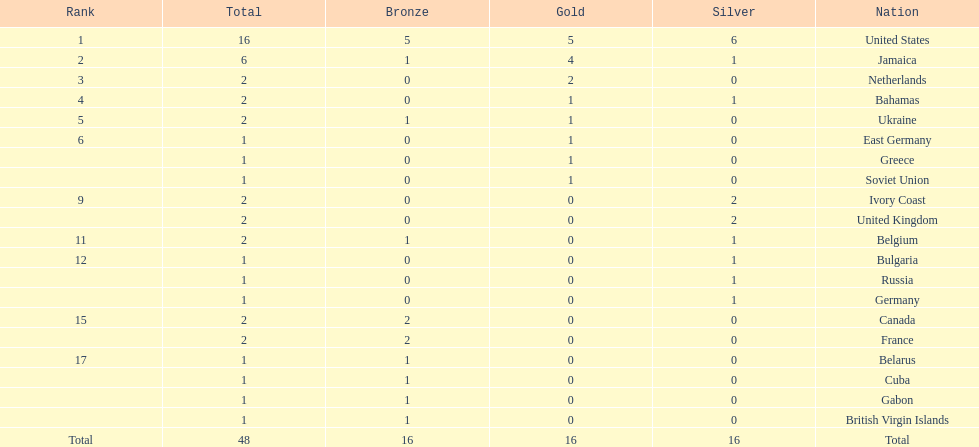What country won the most silver medals? United States. 